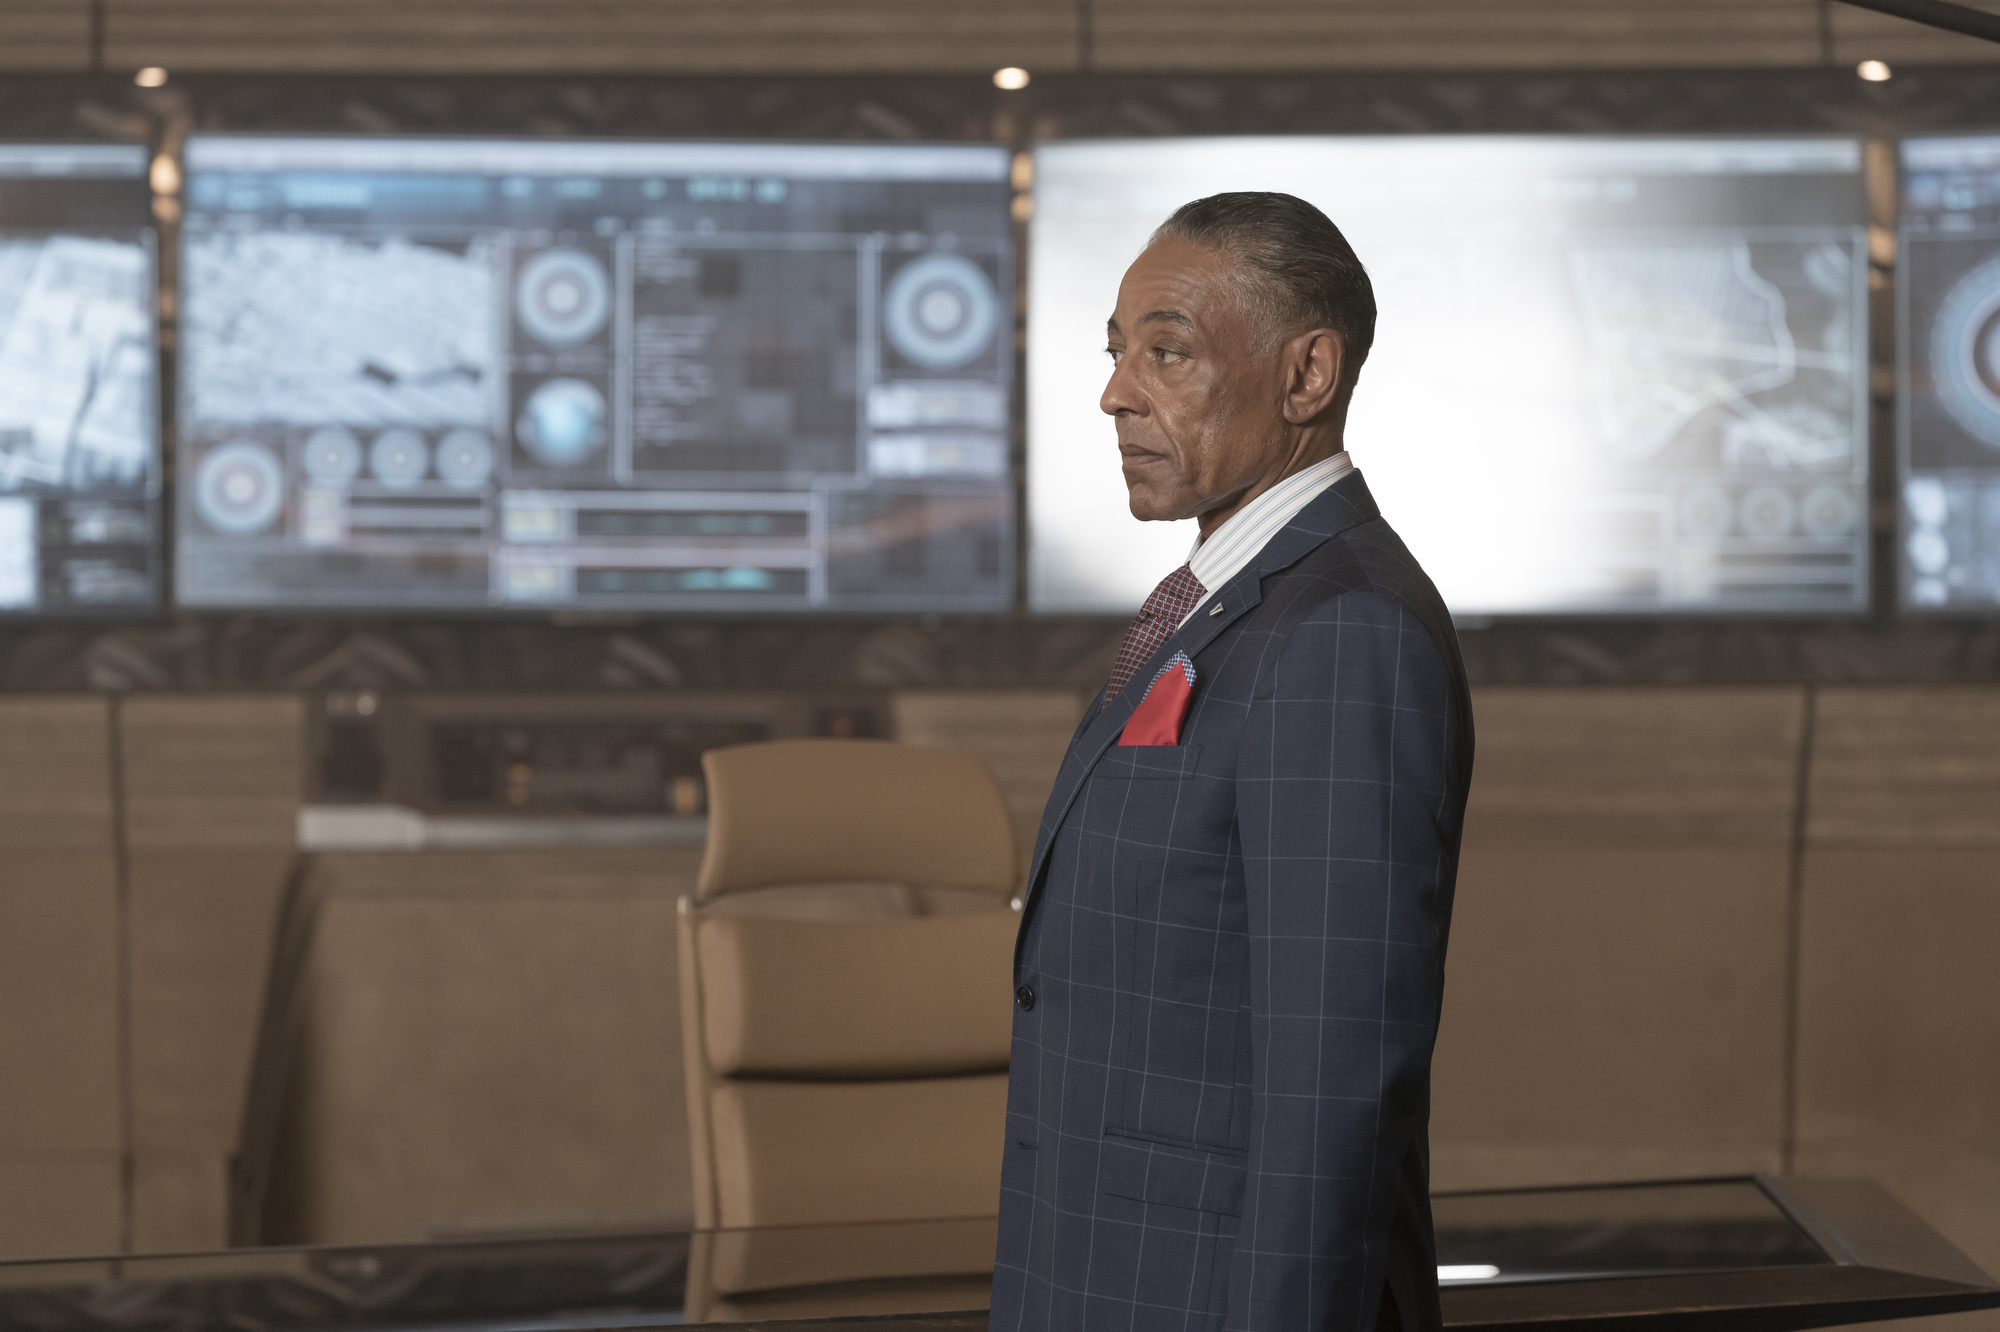How does the attire of the man contribute to the overall impression of the scene? The man's sharp suit and neatly styled appearance contribute significantly to the impression of professionalism and control in the scene. The sophisticated attire suggests that he is a person of importance, likely in a leadership role within the context implied by the high-tech environment. 